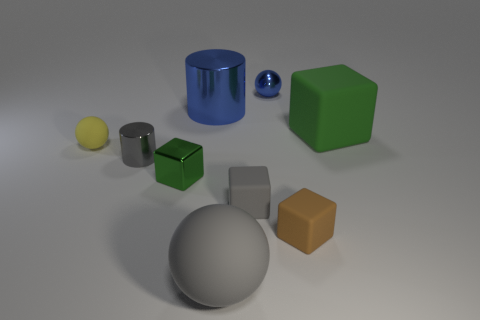Add 1 gray rubber spheres. How many objects exist? 10 Subtract all cylinders. How many objects are left? 7 Add 3 blue things. How many blue things are left? 5 Add 4 blue spheres. How many blue spheres exist? 5 Subtract 0 yellow cylinders. How many objects are left? 9 Subtract all tiny purple shiny spheres. Subtract all tiny metallic spheres. How many objects are left? 8 